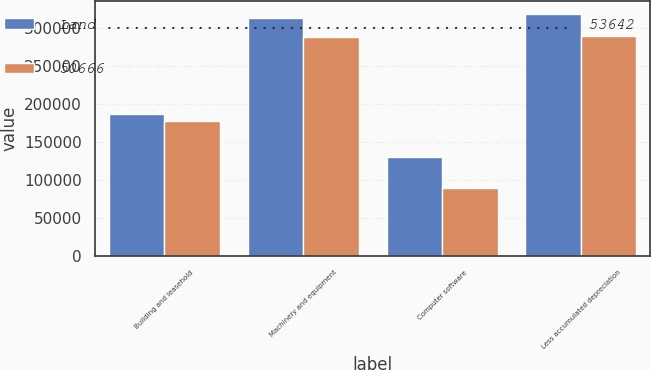Convert chart. <chart><loc_0><loc_0><loc_500><loc_500><stacked_bar_chart><ecel><fcel>Building and leasehold<fcel>Machinery and equipment<fcel>Computer software<fcel>Less accumulated depreciation<nl><fcel>Land ...................................................  53642<fcel>186974<fcel>312501<fcel>129697<fcel>318342<nl><fcel>50666<fcel>177615<fcel>287247<fcel>89523<fcel>288717<nl></chart> 